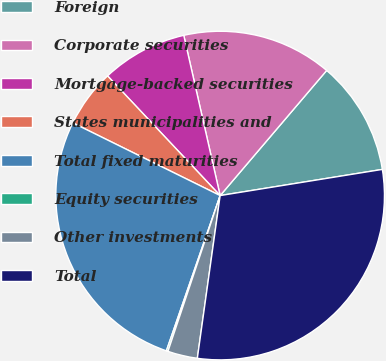<chart> <loc_0><loc_0><loc_500><loc_500><pie_chart><fcel>Foreign<fcel>Corporate securities<fcel>Mortgage-backed securities<fcel>States municipalities and<fcel>Total fixed maturities<fcel>Equity securities<fcel>Other investments<fcel>Total<nl><fcel>11.23%<fcel>14.78%<fcel>8.46%<fcel>5.69%<fcel>26.99%<fcel>0.16%<fcel>2.93%<fcel>29.76%<nl></chart> 